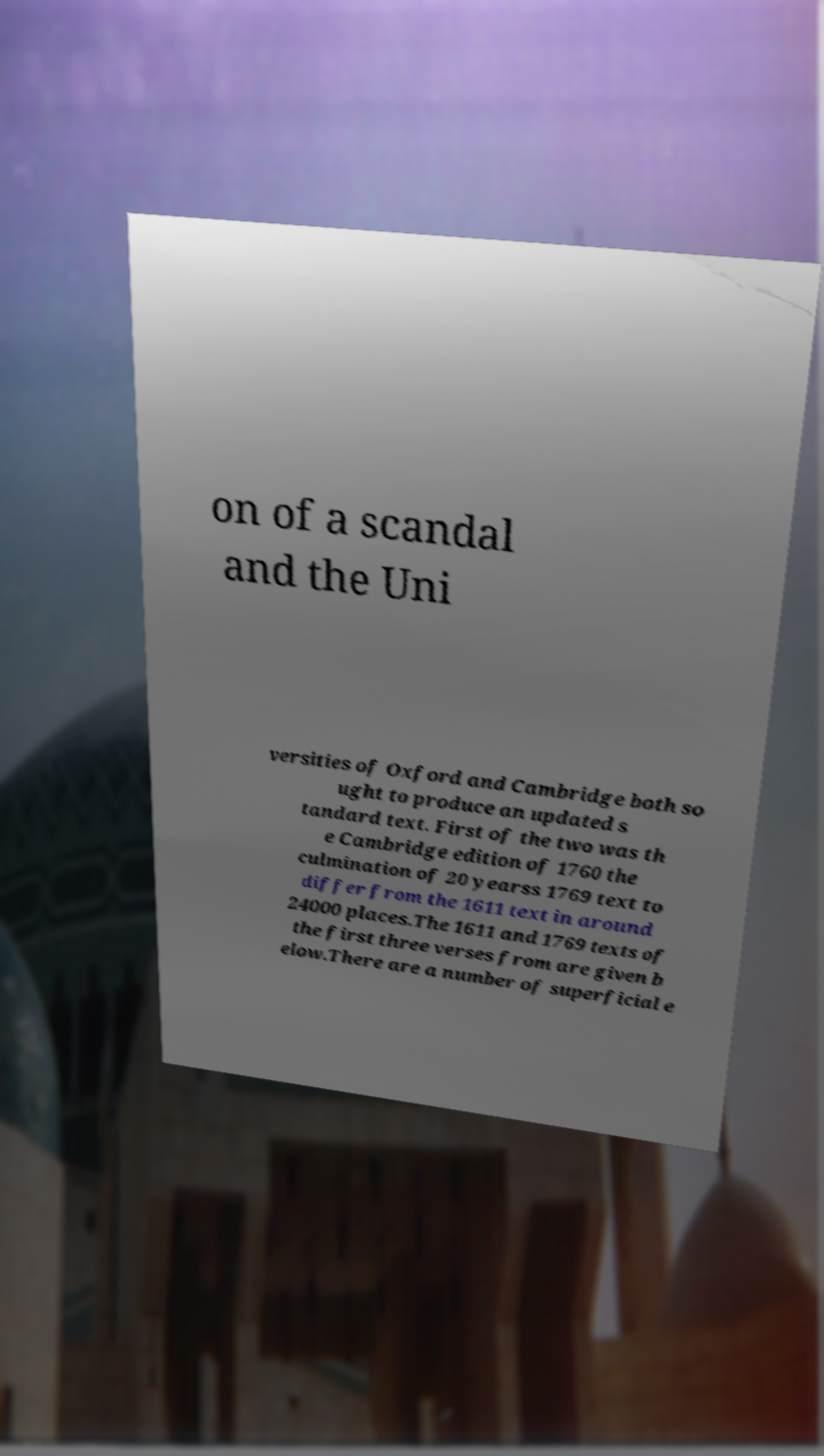Can you read and provide the text displayed in the image?This photo seems to have some interesting text. Can you extract and type it out for me? on of a scandal and the Uni versities of Oxford and Cambridge both so ught to produce an updated s tandard text. First of the two was th e Cambridge edition of 1760 the culmination of 20 yearss 1769 text to differ from the 1611 text in around 24000 places.The 1611 and 1769 texts of the first three verses from are given b elow.There are a number of superficial e 